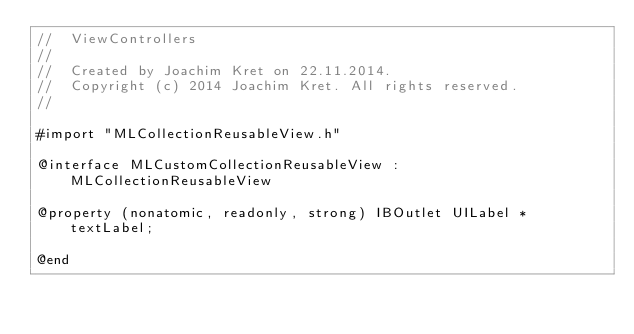<code> <loc_0><loc_0><loc_500><loc_500><_C_>//  ViewControllers
//
//  Created by Joachim Kret on 22.11.2014.
//  Copyright (c) 2014 Joachim Kret. All rights reserved.
//

#import "MLCollectionReusableView.h"

@interface MLCustomCollectionReusableView : MLCollectionReusableView

@property (nonatomic, readonly, strong) IBOutlet UILabel * textLabel;

@end
</code> 